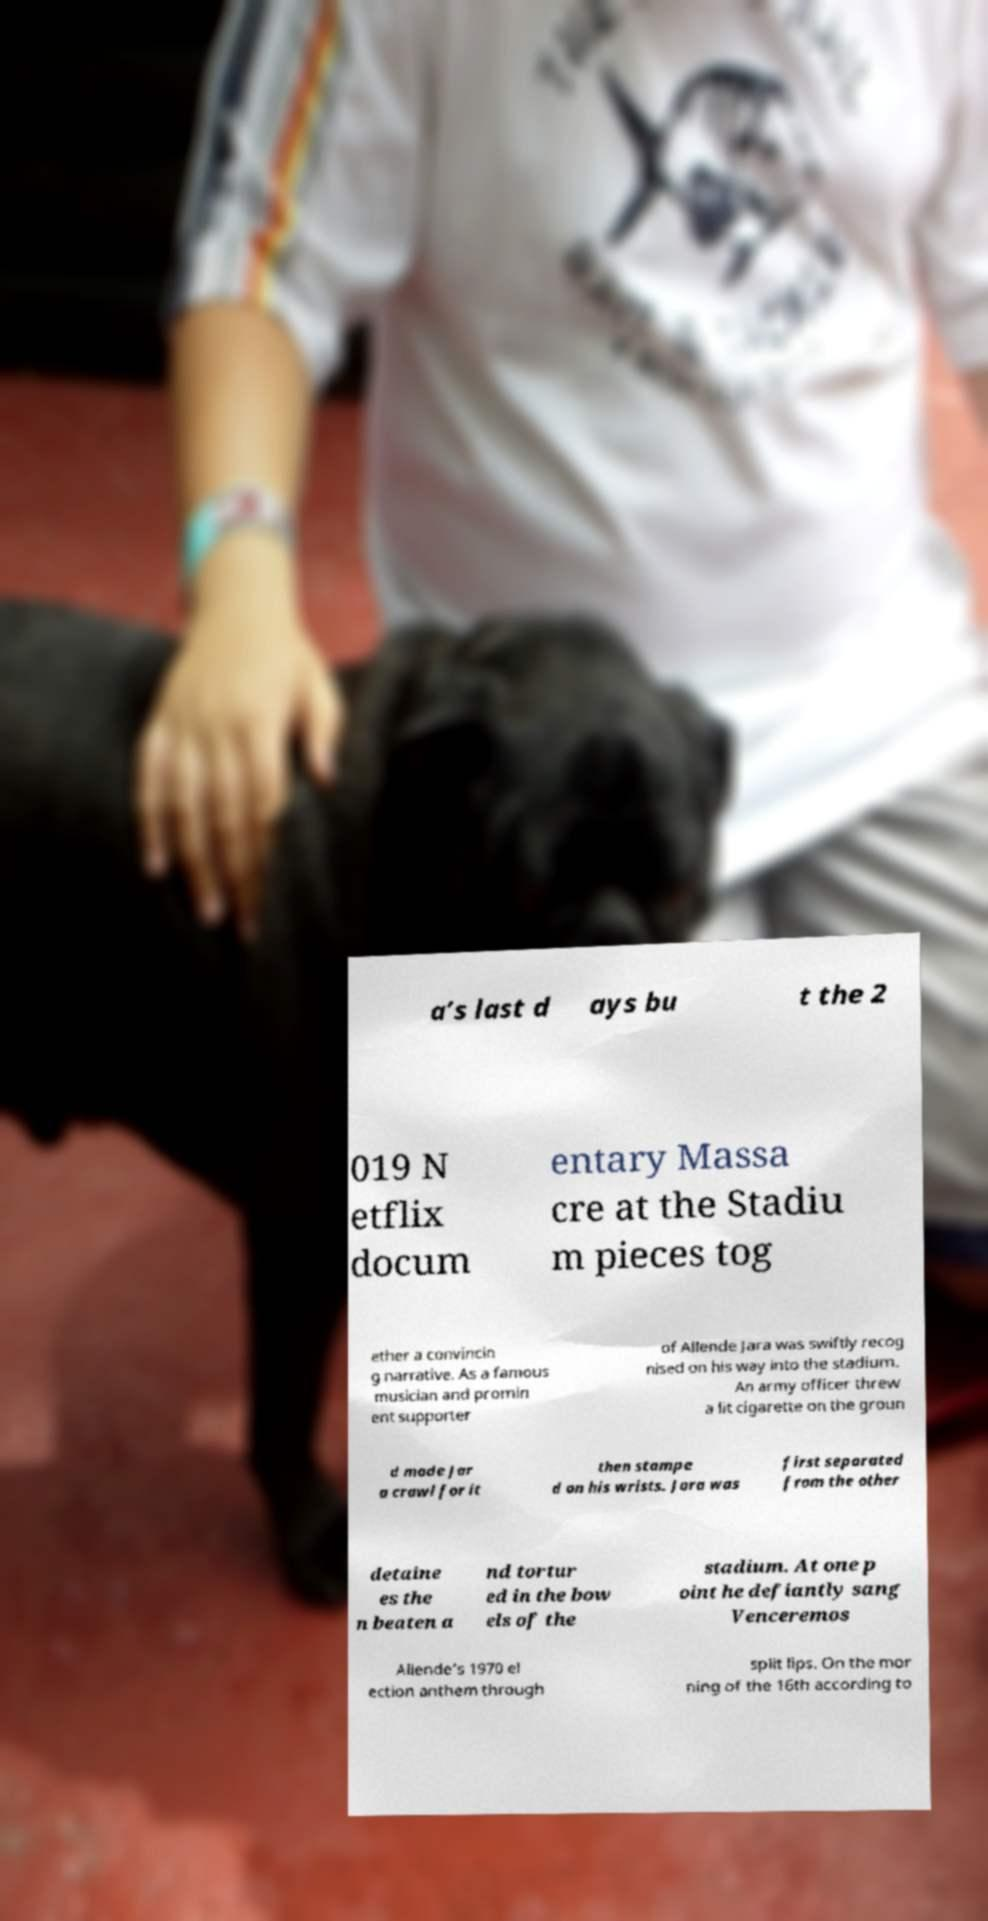Could you extract and type out the text from this image? a’s last d ays bu t the 2 019 N etflix docum entary Massa cre at the Stadiu m pieces tog ether a convincin g narrative. As a famous musician and promin ent supporter of Allende Jara was swiftly recog nised on his way into the stadium. An army officer threw a lit cigarette on the groun d made Jar a crawl for it then stampe d on his wrists. Jara was first separated from the other detaine es the n beaten a nd tortur ed in the bow els of the stadium. At one p oint he defiantly sang Venceremos Allende’s 1970 el ection anthem through split lips. On the mor ning of the 16th according to 